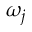<formula> <loc_0><loc_0><loc_500><loc_500>\omega _ { j }</formula> 